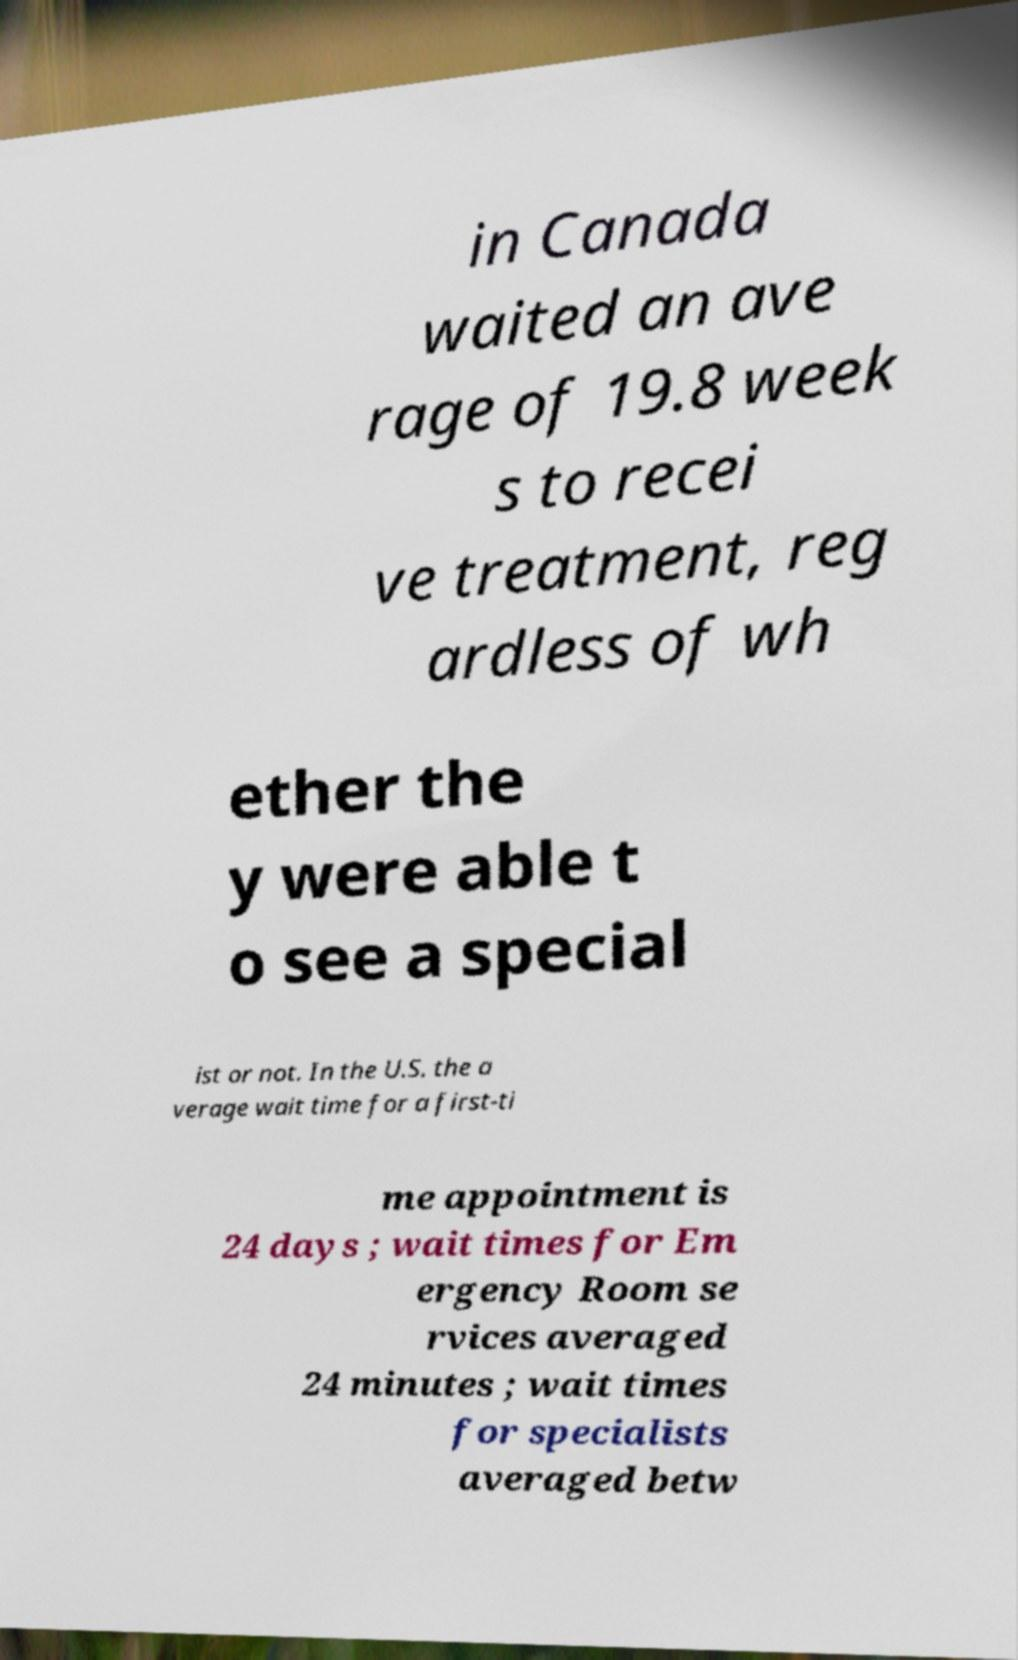What messages or text are displayed in this image? I need them in a readable, typed format. in Canada waited an ave rage of 19.8 week s to recei ve treatment, reg ardless of wh ether the y were able t o see a special ist or not. In the U.S. the a verage wait time for a first-ti me appointment is 24 days ; wait times for Em ergency Room se rvices averaged 24 minutes ; wait times for specialists averaged betw 